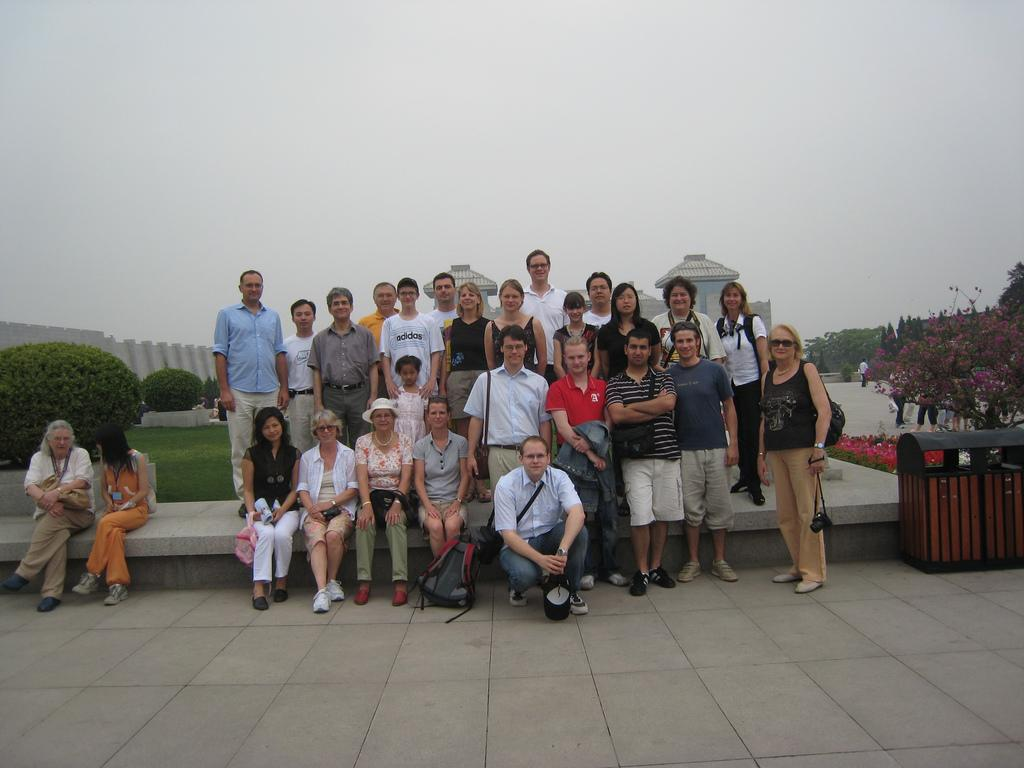How many people are in the group in the image? There is a group of people in the image, but the exact number is not specified. What are some of the people in the group doing? Some people in the group are standing, while others are sitting. What can be seen in the background of the image? There are plants visible in the image, and there is a building behind the group of people. Can you describe the setting of the image? The image shows a group of people in a setting with plants and a building in the background. What type of waves can be seen crashing on the shore in the image? There are no waves or shore visible in the image; it features a group of people with plants and a building in the background. 